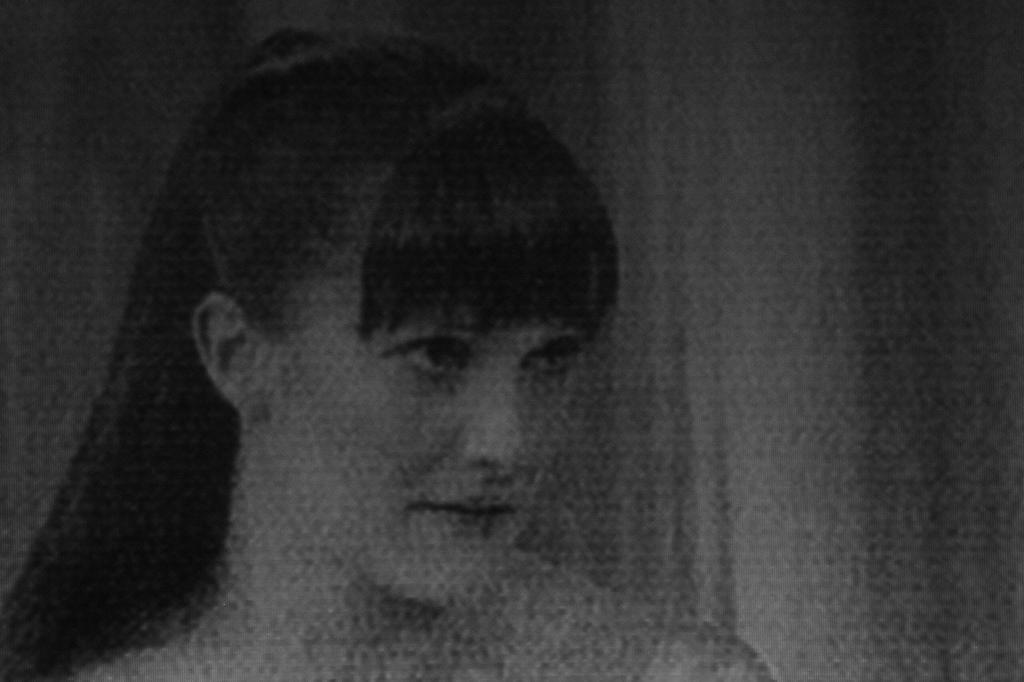How would you summarize this image in a sentence or two? In the picture we can see a woman with a long hair and beside her we can see a curtain which is white in color. 